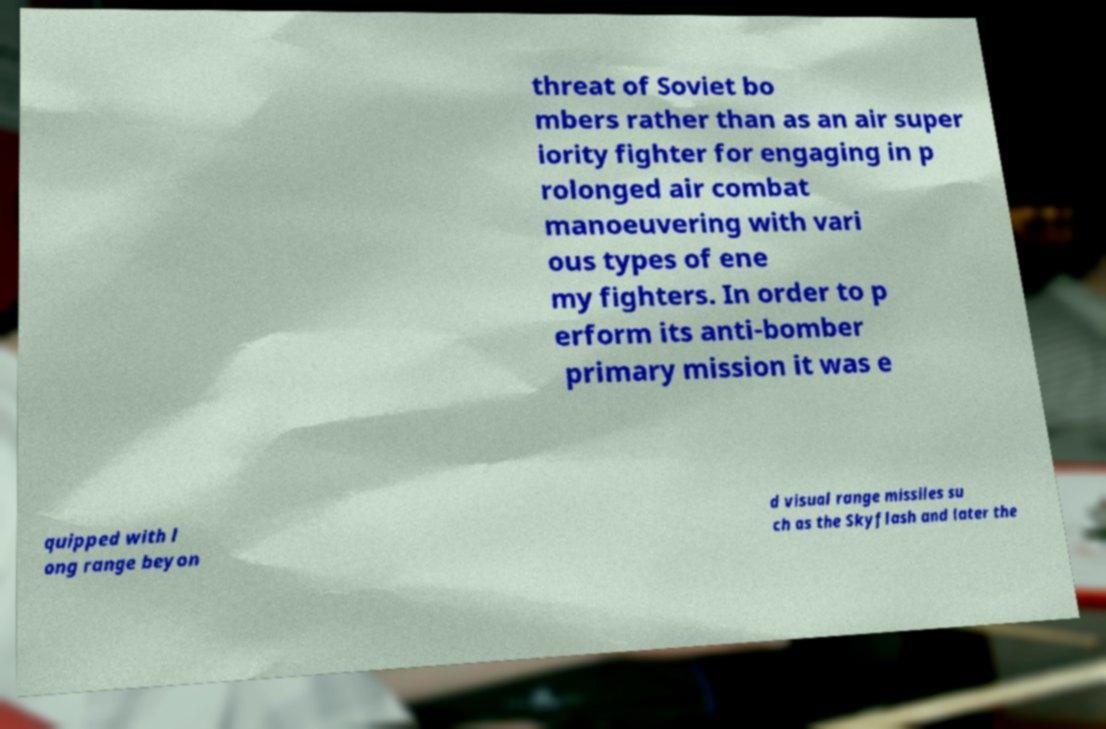Could you extract and type out the text from this image? threat of Soviet bo mbers rather than as an air super iority fighter for engaging in p rolonged air combat manoeuvering with vari ous types of ene my fighters. In order to p erform its anti-bomber primary mission it was e quipped with l ong range beyon d visual range missiles su ch as the Skyflash and later the 